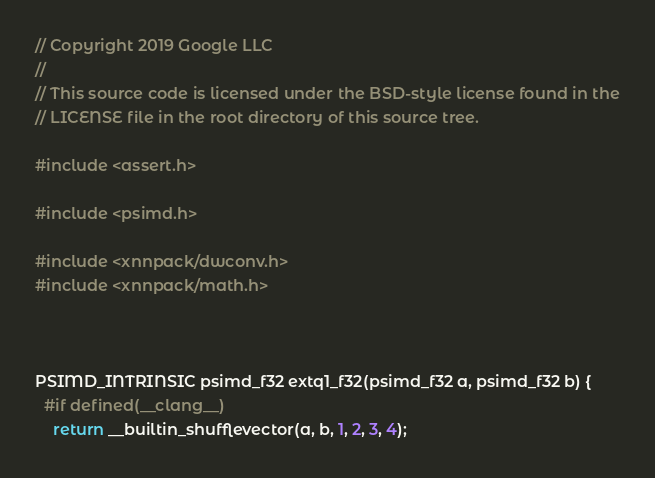<code> <loc_0><loc_0><loc_500><loc_500><_C_>// Copyright 2019 Google LLC
//
// This source code is licensed under the BSD-style license found in the
// LICENSE file in the root directory of this source tree.

#include <assert.h>

#include <psimd.h>

#include <xnnpack/dwconv.h>
#include <xnnpack/math.h>



PSIMD_INTRINSIC psimd_f32 extq1_f32(psimd_f32 a, psimd_f32 b) {
  #if defined(__clang__)
    return __builtin_shufflevector(a, b, 1, 2, 3, 4);</code> 